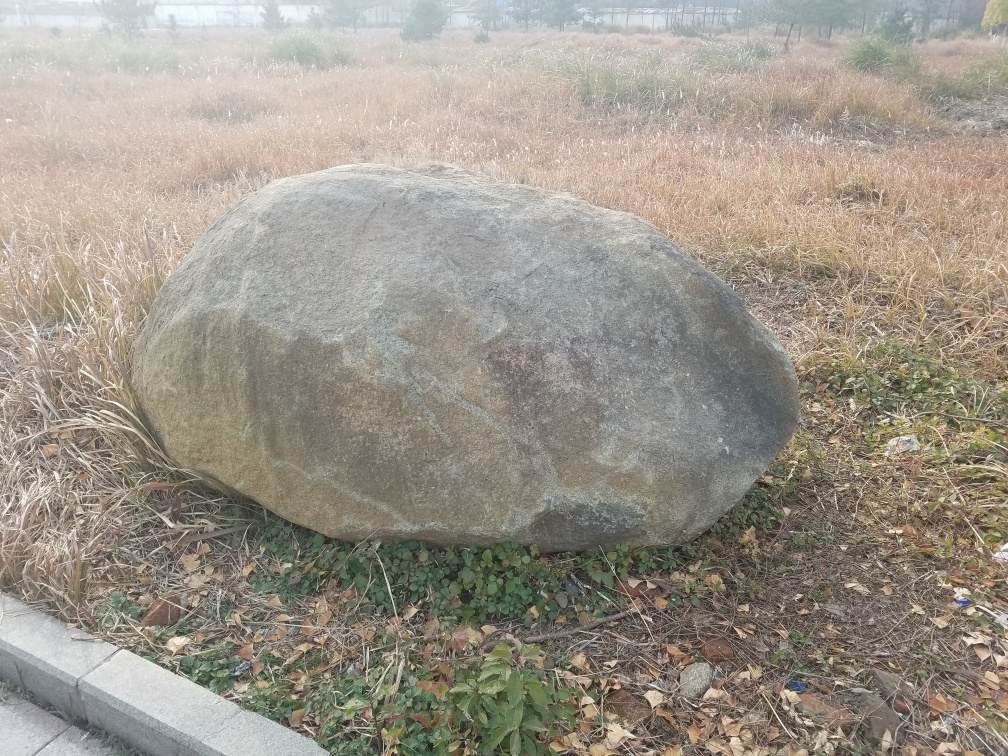Is the quality of this image good? The quality of the image is decent, capturing the boulder with enough detail and clarity to examine its surface and the surrounding dry grass. However, it seems a bit overcast, which may affect the lighting and color vibrancy. Additionally, there's room for improvement in terms of framing and composition to give it a more appealing aesthetic. 